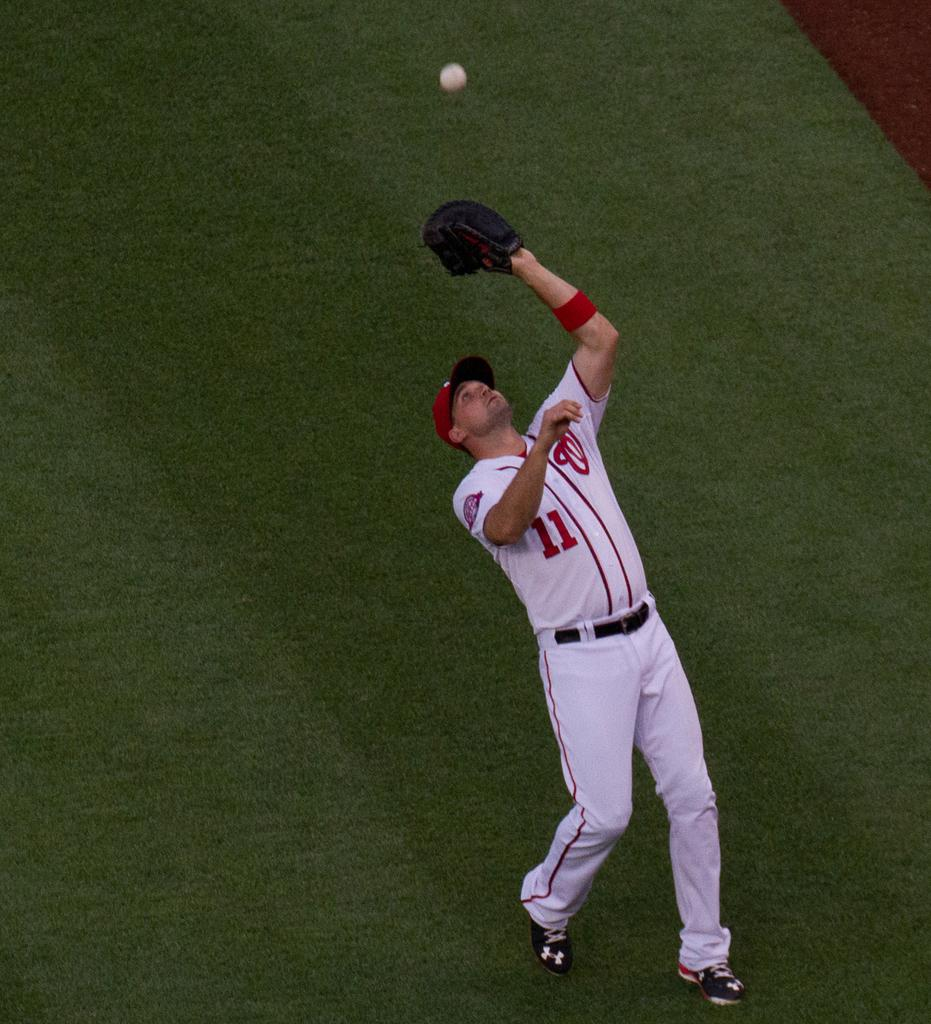<image>
Describe the image concisely. a man in a Nationals jersey catching a ball 